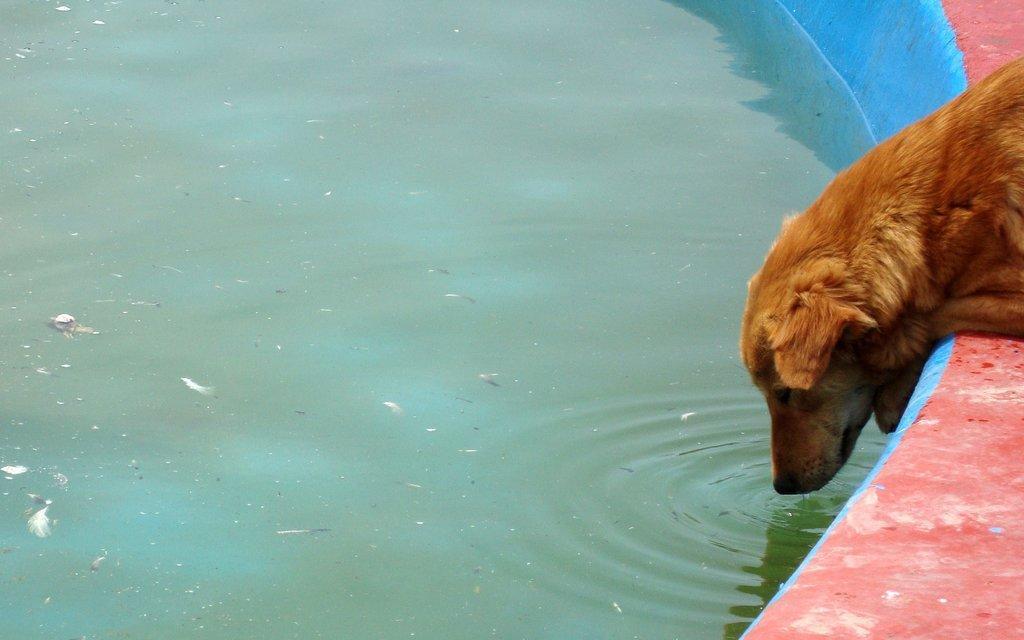How would you summarize this image in a sentence or two? In the image we can see there is a dog sitting near the water. 